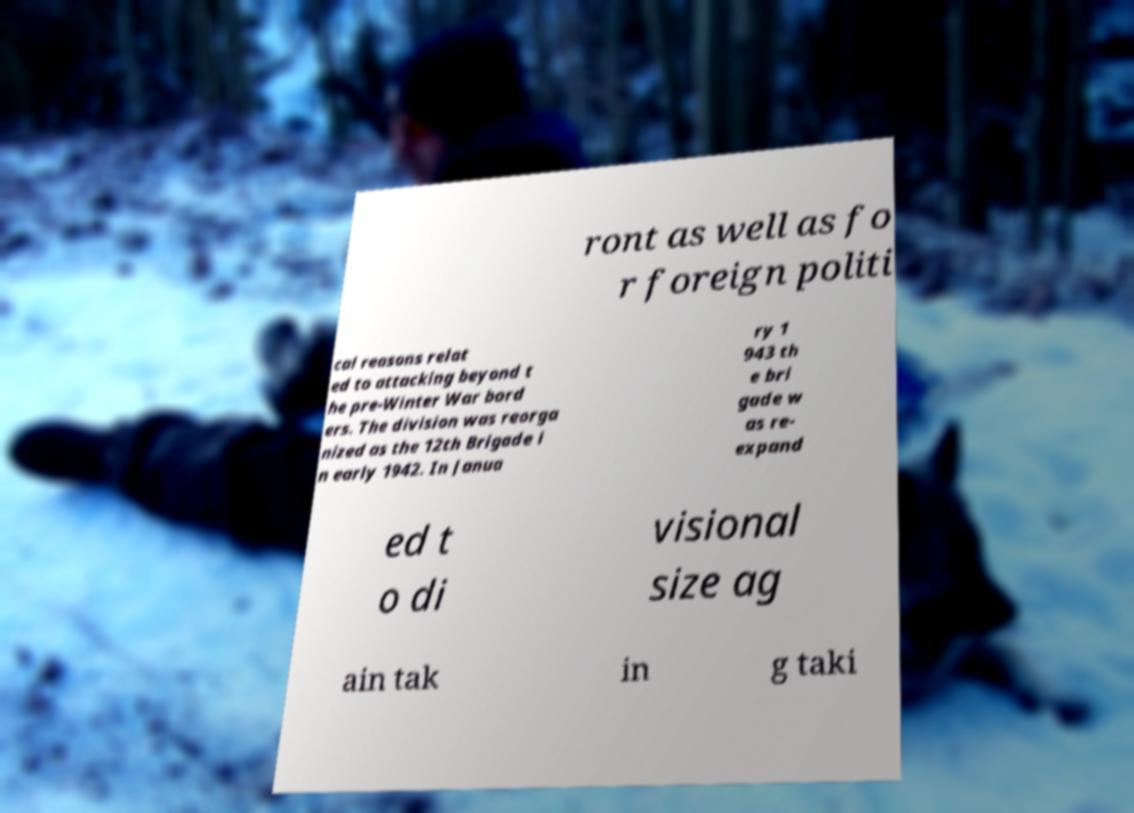For documentation purposes, I need the text within this image transcribed. Could you provide that? ront as well as fo r foreign politi cal reasons relat ed to attacking beyond t he pre-Winter War bord ers. The division was reorga nized as the 12th Brigade i n early 1942. In Janua ry 1 943 th e bri gade w as re- expand ed t o di visional size ag ain tak in g taki 